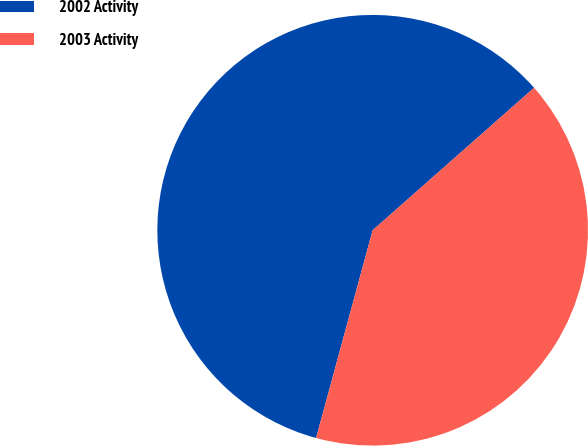<chart> <loc_0><loc_0><loc_500><loc_500><pie_chart><fcel>2002 Activity<fcel>2003 Activity<nl><fcel>59.26%<fcel>40.74%<nl></chart> 